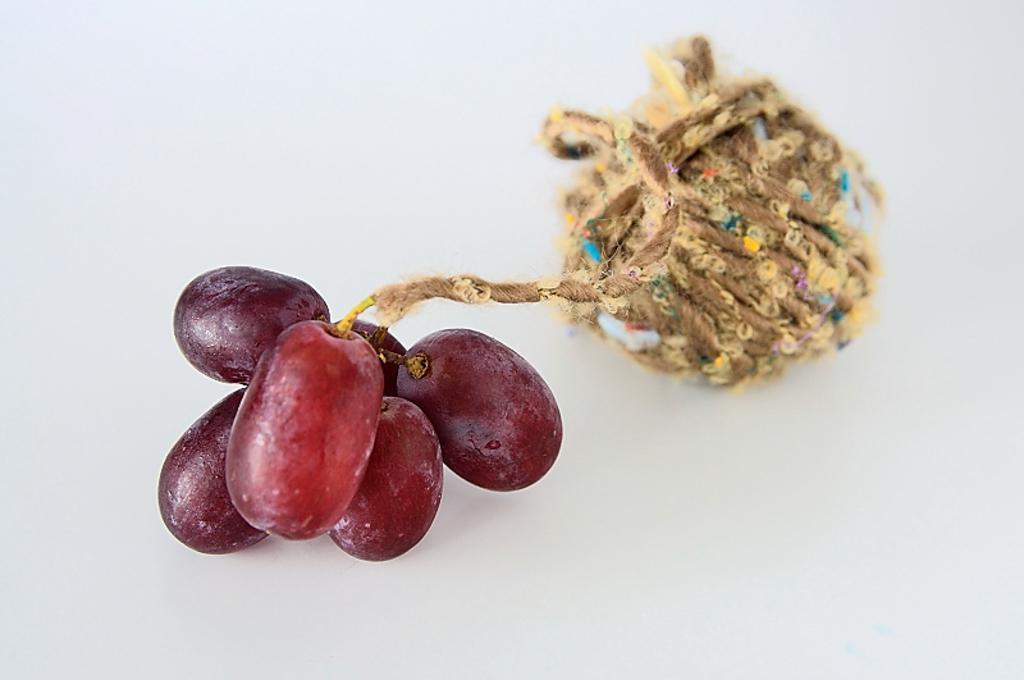In one or two sentences, can you explain what this image depicts? In this image, I can see a small bunch of grapes, which are tied to the rope. The background is white in color. 